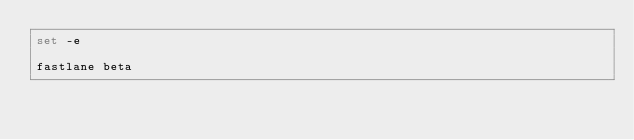<code> <loc_0><loc_0><loc_500><loc_500><_Bash_>set -e

fastlane beta</code> 